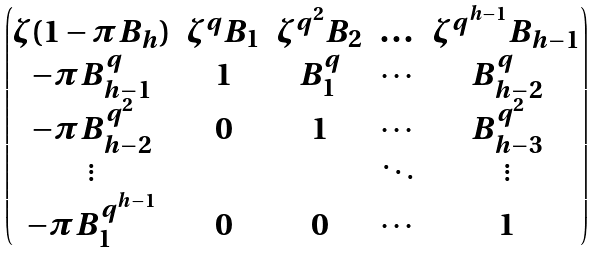<formula> <loc_0><loc_0><loc_500><loc_500>\begin{pmatrix} \zeta ( 1 - \pi B _ { h } ) & \zeta ^ { q } B _ { 1 } & \zeta ^ { q ^ { 2 } } B _ { 2 } & \dots & \zeta ^ { q ^ { h - 1 } } B _ { h - 1 } \\ - \pi B _ { h - 1 } ^ { q } & 1 & B _ { 1 } ^ { q } & \cdots & B _ { h - 2 } ^ { q } \\ - \pi B _ { h - 2 } ^ { q ^ { 2 } } & 0 & 1 & \cdots & B _ { h - 3 } ^ { q ^ { 2 } } \\ \vdots & & & \ddots & \vdots \\ - \pi B _ { 1 } ^ { q ^ { h - 1 } } & 0 & 0 & \cdots & 1 \end{pmatrix}</formula> 